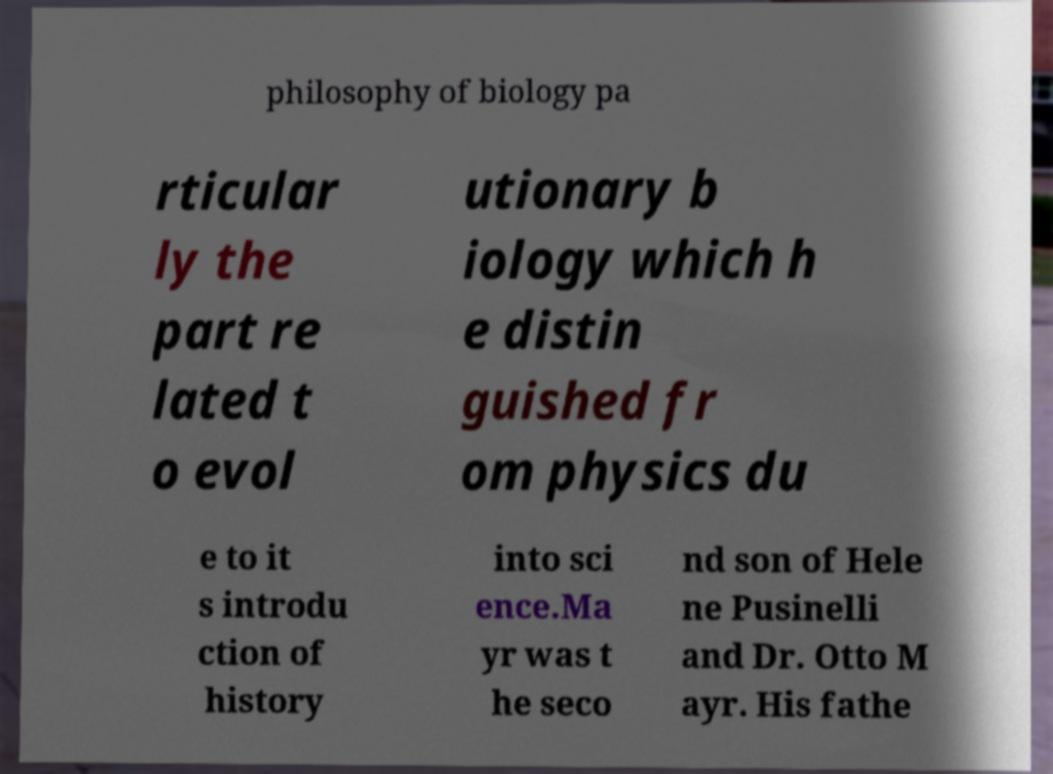Please identify and transcribe the text found in this image. philosophy of biology pa rticular ly the part re lated t o evol utionary b iology which h e distin guished fr om physics du e to it s introdu ction of history into sci ence.Ma yr was t he seco nd son of Hele ne Pusinelli and Dr. Otto M ayr. His fathe 